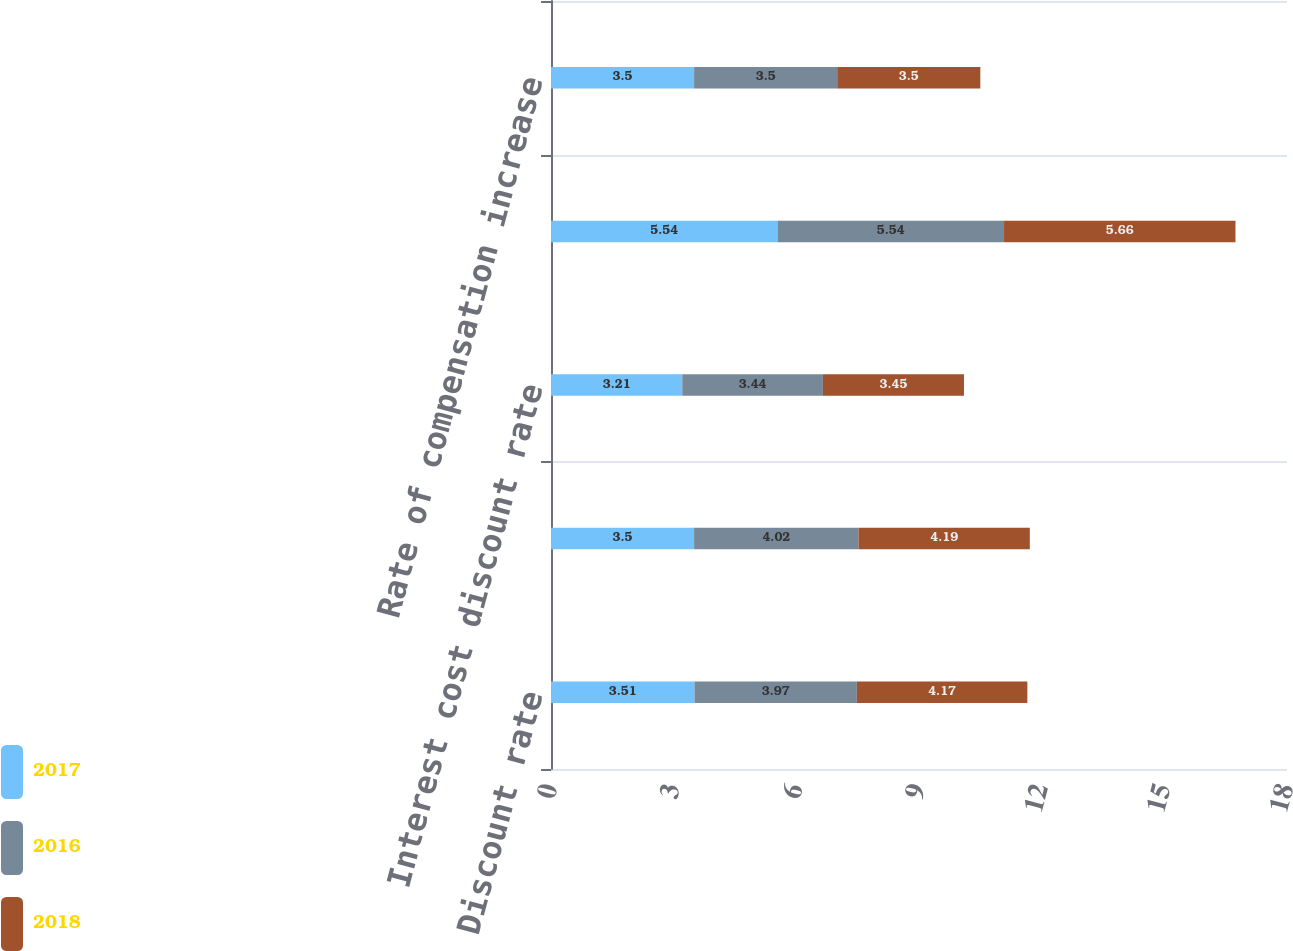<chart> <loc_0><loc_0><loc_500><loc_500><stacked_bar_chart><ecel><fcel>Discount rate<fcel>Service cost discount rate (a)<fcel>Interest cost discount rate<fcel>Expected return on plan assets<fcel>Rate of compensation increase<nl><fcel>2017<fcel>3.51<fcel>3.5<fcel>3.21<fcel>5.54<fcel>3.5<nl><fcel>2016<fcel>3.97<fcel>4.02<fcel>3.44<fcel>5.54<fcel>3.5<nl><fcel>2018<fcel>4.17<fcel>4.19<fcel>3.45<fcel>5.66<fcel>3.5<nl></chart> 